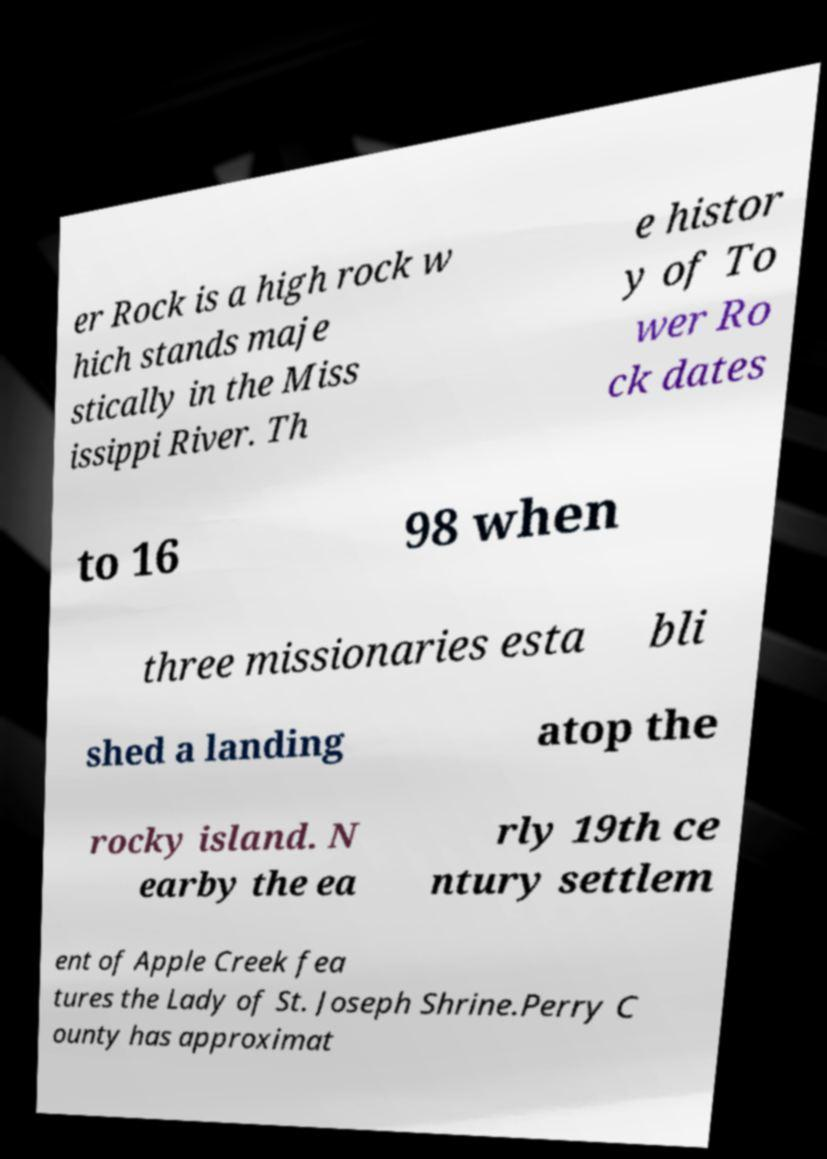There's text embedded in this image that I need extracted. Can you transcribe it verbatim? er Rock is a high rock w hich stands maje stically in the Miss issippi River. Th e histor y of To wer Ro ck dates to 16 98 when three missionaries esta bli shed a landing atop the rocky island. N earby the ea rly 19th ce ntury settlem ent of Apple Creek fea tures the Lady of St. Joseph Shrine.Perry C ounty has approximat 